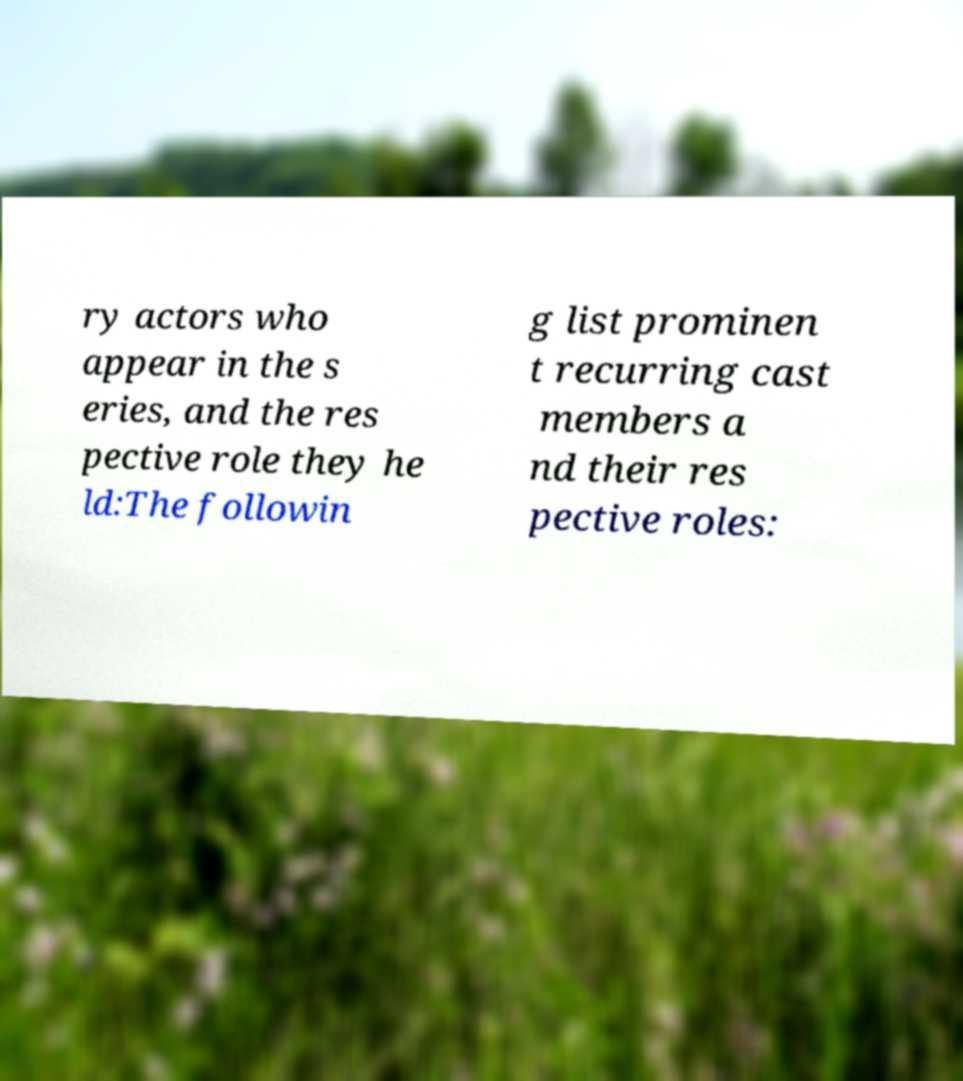Can you read and provide the text displayed in the image?This photo seems to have some interesting text. Can you extract and type it out for me? ry actors who appear in the s eries, and the res pective role they he ld:The followin g list prominen t recurring cast members a nd their res pective roles: 